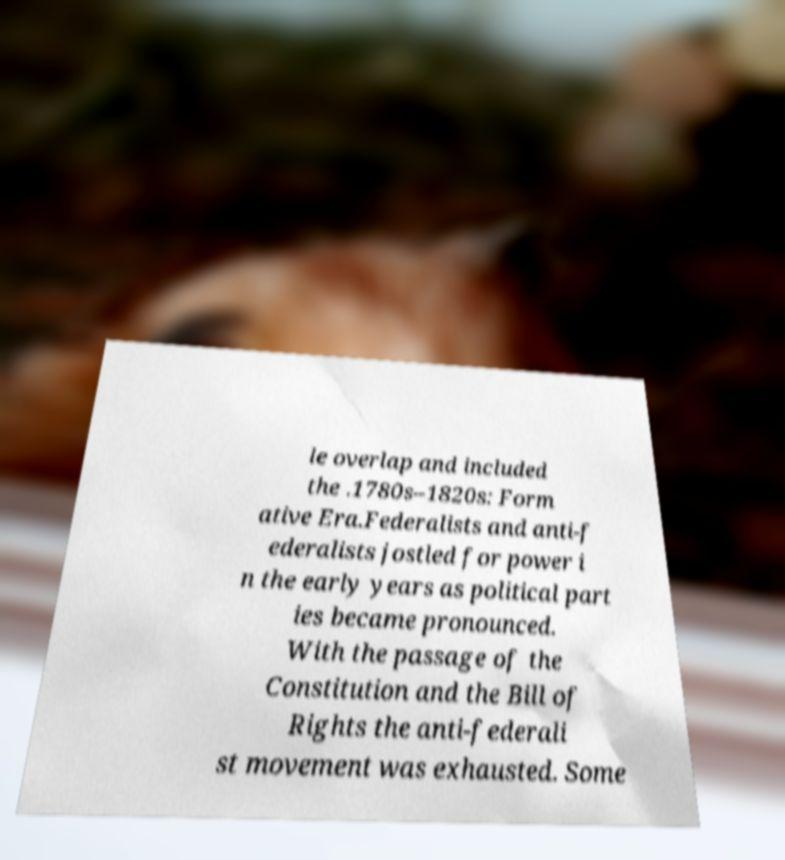Can you read and provide the text displayed in the image?This photo seems to have some interesting text. Can you extract and type it out for me? le overlap and included the .1780s–1820s: Form ative Era.Federalists and anti-f ederalists jostled for power i n the early years as political part ies became pronounced. With the passage of the Constitution and the Bill of Rights the anti-federali st movement was exhausted. Some 